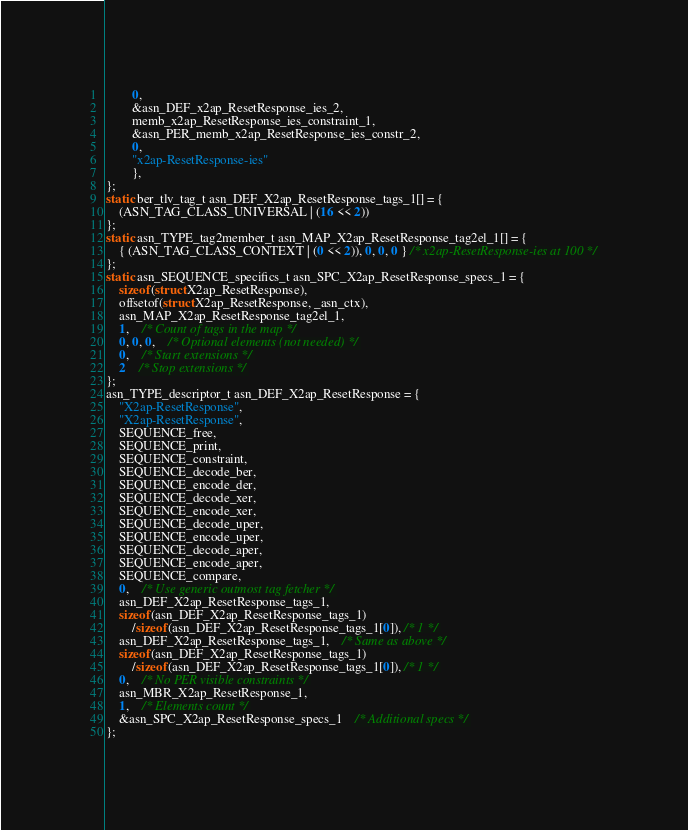<code> <loc_0><loc_0><loc_500><loc_500><_C_>		0,
		&asn_DEF_x2ap_ResetResponse_ies_2,
		memb_x2ap_ResetResponse_ies_constraint_1,
		&asn_PER_memb_x2ap_ResetResponse_ies_constr_2,
		0,
		"x2ap-ResetResponse-ies"
		},
};
static ber_tlv_tag_t asn_DEF_X2ap_ResetResponse_tags_1[] = {
	(ASN_TAG_CLASS_UNIVERSAL | (16 << 2))
};
static asn_TYPE_tag2member_t asn_MAP_X2ap_ResetResponse_tag2el_1[] = {
    { (ASN_TAG_CLASS_CONTEXT | (0 << 2)), 0, 0, 0 } /* x2ap-ResetResponse-ies at 100 */
};
static asn_SEQUENCE_specifics_t asn_SPC_X2ap_ResetResponse_specs_1 = {
	sizeof(struct X2ap_ResetResponse),
	offsetof(struct X2ap_ResetResponse, _asn_ctx),
	asn_MAP_X2ap_ResetResponse_tag2el_1,
	1,	/* Count of tags in the map */
	0, 0, 0,	/* Optional elements (not needed) */
	0,	/* Start extensions */
	2	/* Stop extensions */
};
asn_TYPE_descriptor_t asn_DEF_X2ap_ResetResponse = {
	"X2ap-ResetResponse",
	"X2ap-ResetResponse",
	SEQUENCE_free,
	SEQUENCE_print,
	SEQUENCE_constraint,
	SEQUENCE_decode_ber,
	SEQUENCE_encode_der,
	SEQUENCE_decode_xer,
	SEQUENCE_encode_xer,
	SEQUENCE_decode_uper,
	SEQUENCE_encode_uper,
	SEQUENCE_decode_aper,
	SEQUENCE_encode_aper,
	SEQUENCE_compare,
	0,	/* Use generic outmost tag fetcher */
	asn_DEF_X2ap_ResetResponse_tags_1,
	sizeof(asn_DEF_X2ap_ResetResponse_tags_1)
		/sizeof(asn_DEF_X2ap_ResetResponse_tags_1[0]), /* 1 */
	asn_DEF_X2ap_ResetResponse_tags_1,	/* Same as above */
	sizeof(asn_DEF_X2ap_ResetResponse_tags_1)
		/sizeof(asn_DEF_X2ap_ResetResponse_tags_1[0]), /* 1 */
	0,	/* No PER visible constraints */
	asn_MBR_X2ap_ResetResponse_1,
	1,	/* Elements count */
	&asn_SPC_X2ap_ResetResponse_specs_1	/* Additional specs */
};

</code> 